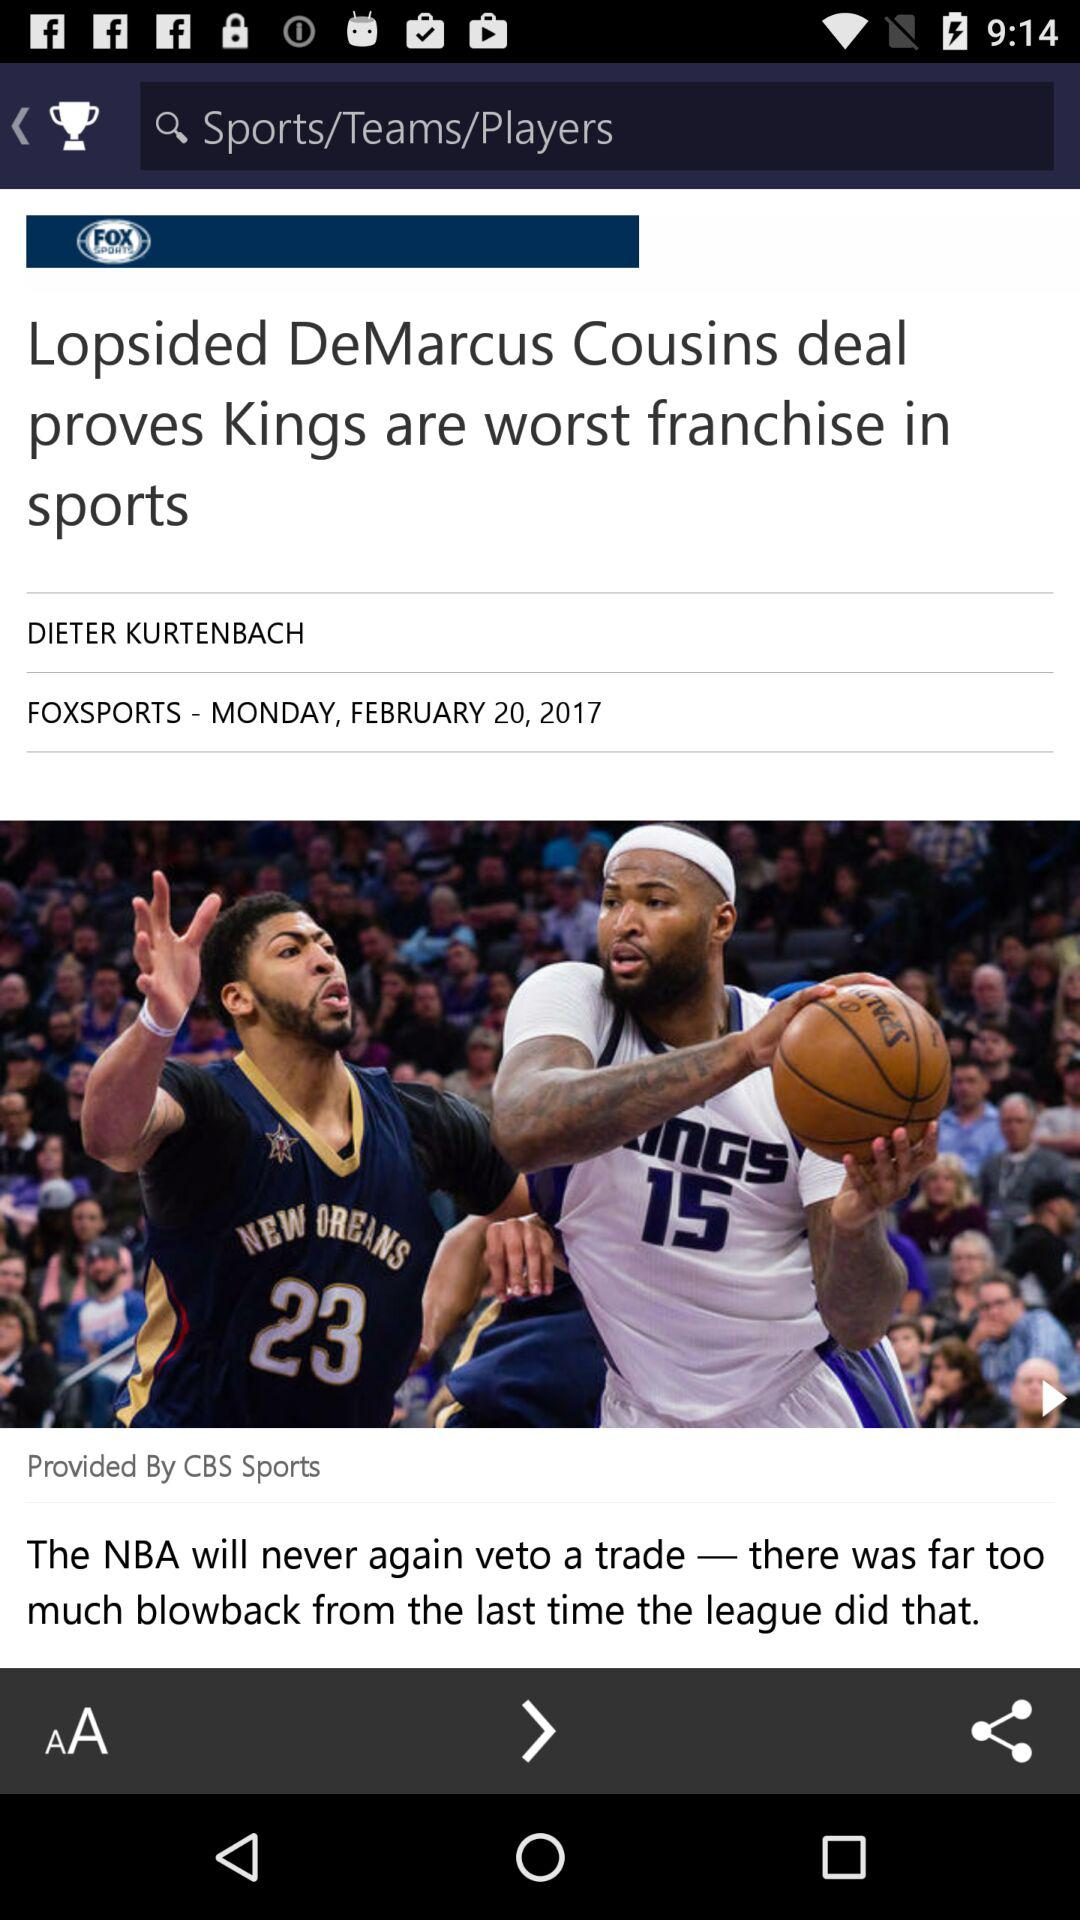Who is the author of the article? The author of the article is Dieter Kurtenbach. 